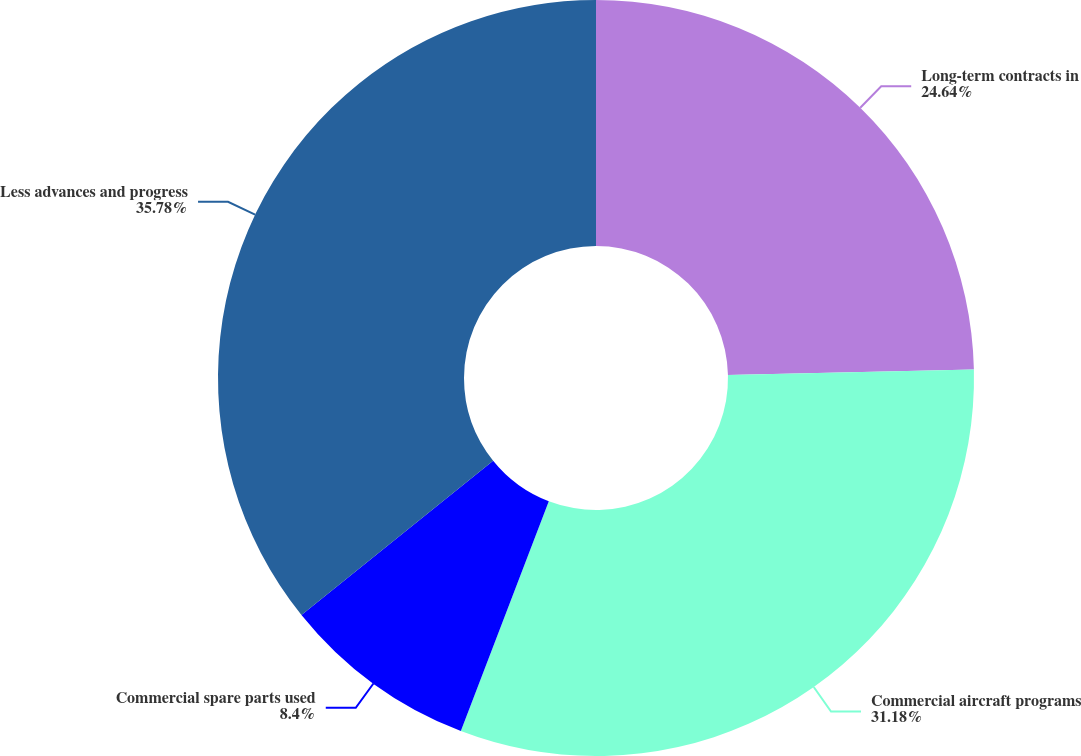Convert chart to OTSL. <chart><loc_0><loc_0><loc_500><loc_500><pie_chart><fcel>Long-term contracts in<fcel>Commercial aircraft programs<fcel>Commercial spare parts used<fcel>Less advances and progress<nl><fcel>24.64%<fcel>31.18%<fcel>8.4%<fcel>35.78%<nl></chart> 